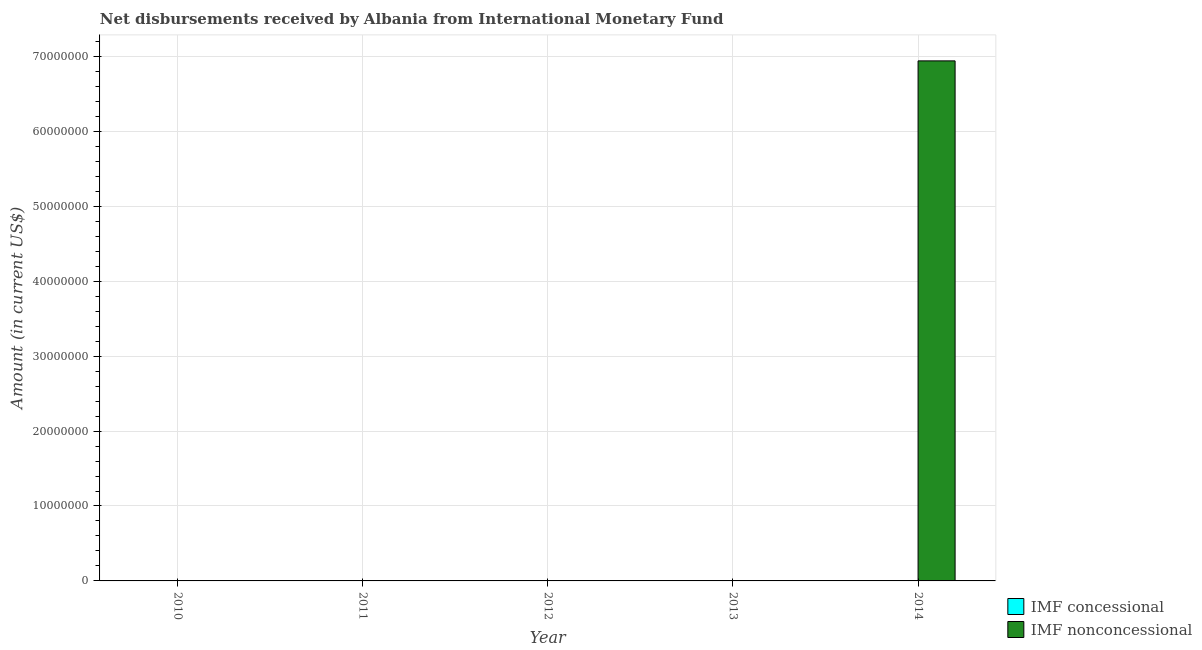How many different coloured bars are there?
Provide a succinct answer. 1. How many bars are there on the 5th tick from the left?
Provide a succinct answer. 1. What is the label of the 4th group of bars from the left?
Offer a terse response. 2013. In how many cases, is the number of bars for a given year not equal to the number of legend labels?
Your response must be concise. 5. What is the net non concessional disbursements from imf in 2010?
Offer a terse response. 0. Across all years, what is the maximum net non concessional disbursements from imf?
Make the answer very short. 6.94e+07. What is the total net concessional disbursements from imf in the graph?
Ensure brevity in your answer.  0. What is the average net non concessional disbursements from imf per year?
Keep it short and to the point. 1.39e+07. What is the difference between the highest and the lowest net non concessional disbursements from imf?
Offer a terse response. 6.94e+07. In how many years, is the net non concessional disbursements from imf greater than the average net non concessional disbursements from imf taken over all years?
Give a very brief answer. 1. How many bars are there?
Provide a succinct answer. 1. Are the values on the major ticks of Y-axis written in scientific E-notation?
Provide a short and direct response. No. Does the graph contain any zero values?
Keep it short and to the point. Yes. Does the graph contain grids?
Make the answer very short. Yes. How are the legend labels stacked?
Provide a short and direct response. Vertical. What is the title of the graph?
Provide a short and direct response. Net disbursements received by Albania from International Monetary Fund. Does "Drinking water services" appear as one of the legend labels in the graph?
Offer a terse response. No. What is the label or title of the X-axis?
Your answer should be very brief. Year. What is the label or title of the Y-axis?
Your response must be concise. Amount (in current US$). What is the Amount (in current US$) of IMF nonconcessional in 2011?
Give a very brief answer. 0. What is the Amount (in current US$) of IMF nonconcessional in 2012?
Your answer should be compact. 0. What is the Amount (in current US$) of IMF concessional in 2013?
Provide a short and direct response. 0. What is the Amount (in current US$) of IMF nonconcessional in 2013?
Provide a short and direct response. 0. What is the Amount (in current US$) in IMF nonconcessional in 2014?
Keep it short and to the point. 6.94e+07. Across all years, what is the maximum Amount (in current US$) in IMF nonconcessional?
Your response must be concise. 6.94e+07. What is the total Amount (in current US$) in IMF concessional in the graph?
Provide a short and direct response. 0. What is the total Amount (in current US$) in IMF nonconcessional in the graph?
Provide a succinct answer. 6.94e+07. What is the average Amount (in current US$) in IMF nonconcessional per year?
Your answer should be very brief. 1.39e+07. What is the difference between the highest and the lowest Amount (in current US$) in IMF nonconcessional?
Your response must be concise. 6.94e+07. 